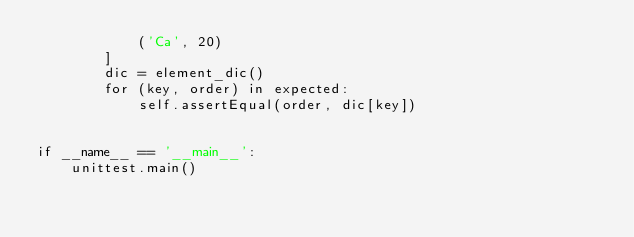<code> <loc_0><loc_0><loc_500><loc_500><_Python_>            ('Ca', 20)
        ]
        dic = element_dic()
        for (key, order) in expected:
            self.assertEqual(order, dic[key])


if __name__ == '__main__':
    unittest.main()
</code> 